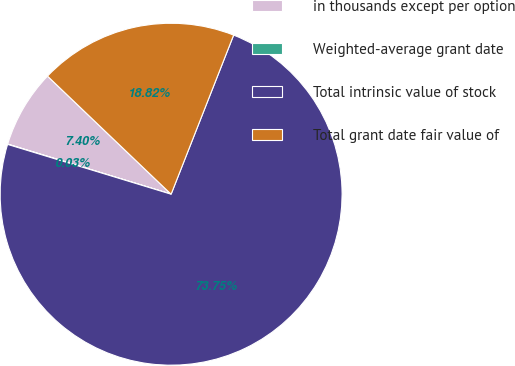<chart> <loc_0><loc_0><loc_500><loc_500><pie_chart><fcel>in thousands except per option<fcel>Weighted-average grant date<fcel>Total intrinsic value of stock<fcel>Total grant date fair value of<nl><fcel>7.4%<fcel>0.03%<fcel>73.74%<fcel>18.82%<nl></chart> 